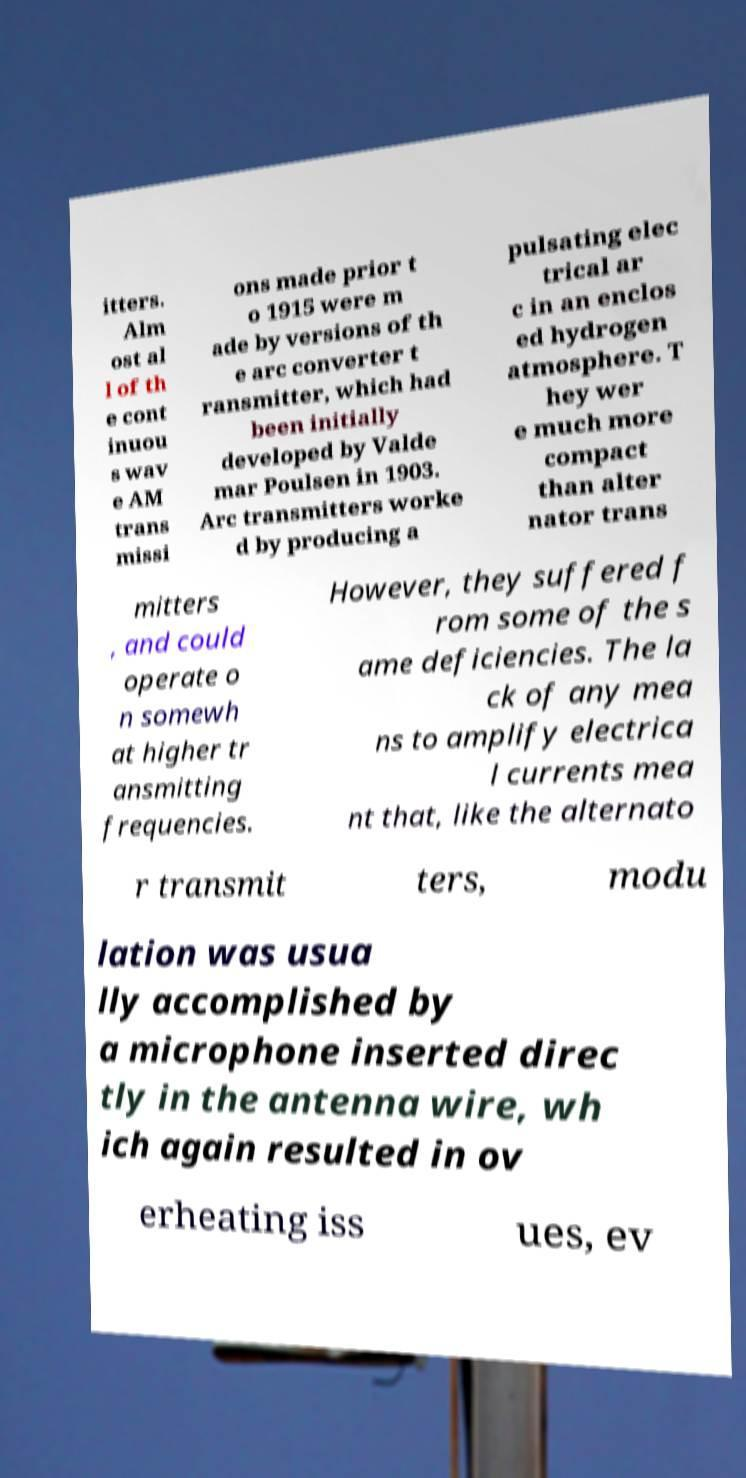Can you read and provide the text displayed in the image?This photo seems to have some interesting text. Can you extract and type it out for me? itters. Alm ost al l of th e cont inuou s wav e AM trans missi ons made prior t o 1915 were m ade by versions of th e arc converter t ransmitter, which had been initially developed by Valde mar Poulsen in 1903. Arc transmitters worke d by producing a pulsating elec trical ar c in an enclos ed hydrogen atmosphere. T hey wer e much more compact than alter nator trans mitters , and could operate o n somewh at higher tr ansmitting frequencies. However, they suffered f rom some of the s ame deficiencies. The la ck of any mea ns to amplify electrica l currents mea nt that, like the alternato r transmit ters, modu lation was usua lly accomplished by a microphone inserted direc tly in the antenna wire, wh ich again resulted in ov erheating iss ues, ev 